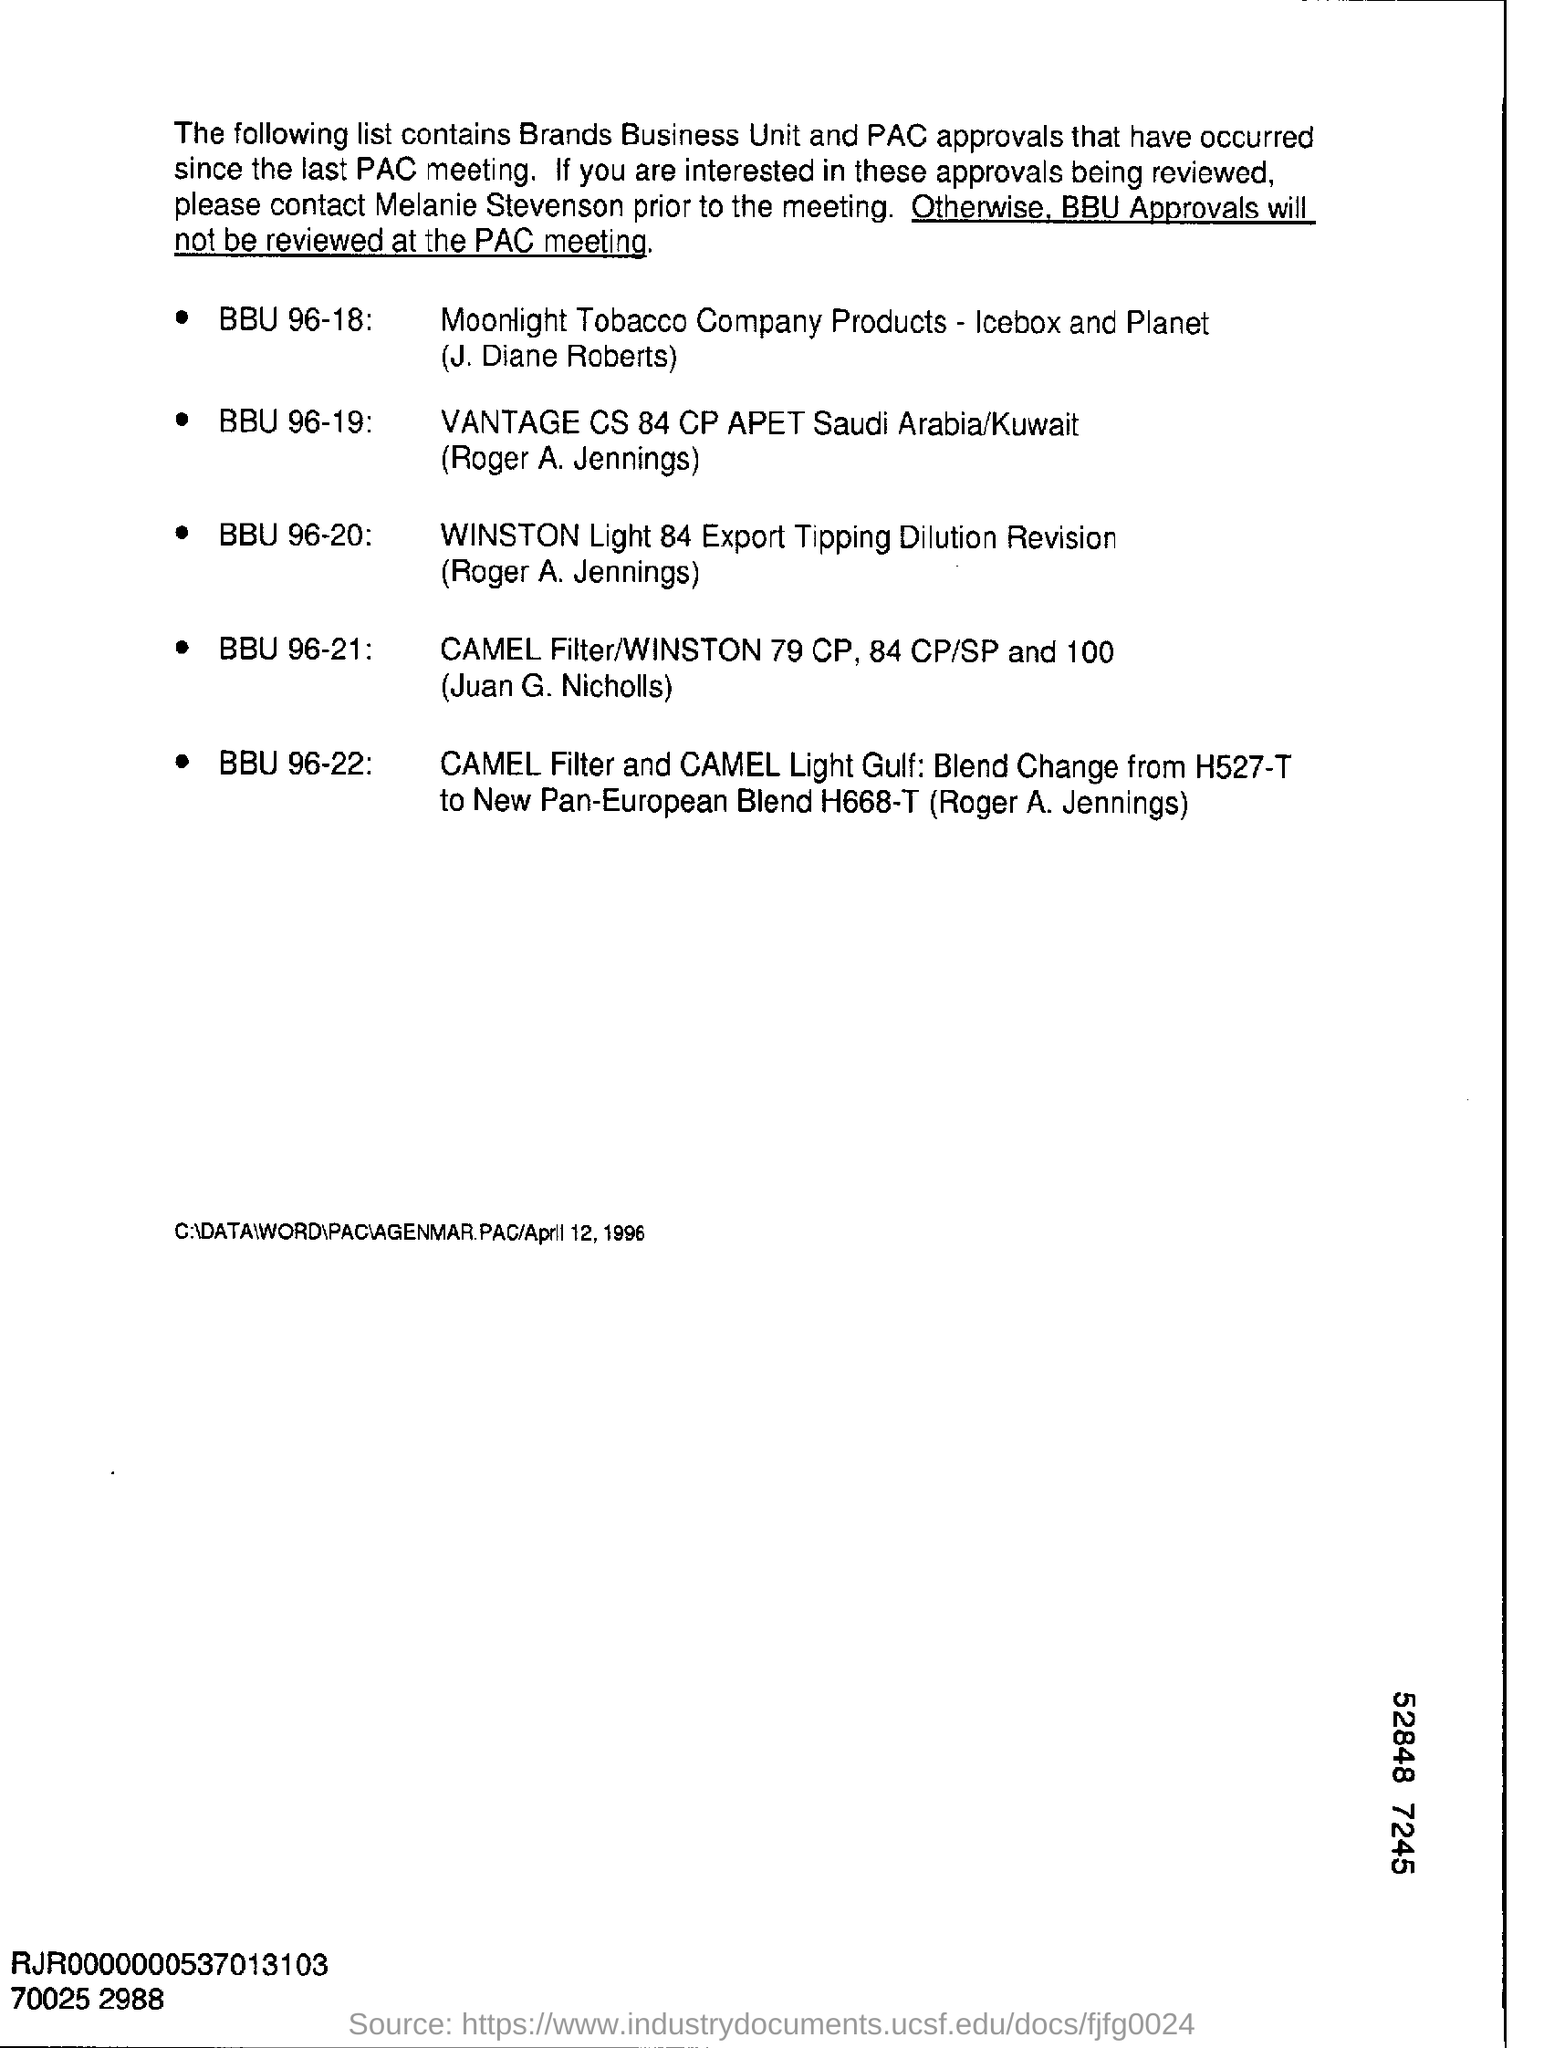Identify some key points in this picture. The list contains information regarding brands, business units, and approvals that have taken place since the last PAC meeting. 